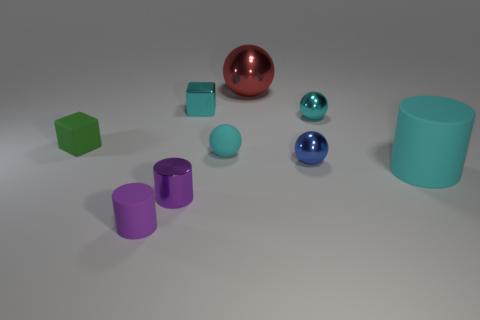Are there an equal number of tiny green blocks in front of the tiny green thing and tiny cylinders?
Keep it short and to the point. No. The purple matte thing that is the same shape as the purple metal object is what size?
Ensure brevity in your answer.  Small. There is a blue metal object; does it have the same shape as the object to the left of the small purple rubber cylinder?
Make the answer very short. No. What size is the purple cylinder that is in front of the tiny purple object that is behind the small purple rubber object?
Provide a short and direct response. Small. Are there the same number of cyan metallic objects that are in front of the small blue sphere and red balls behind the tiny cyan matte ball?
Give a very brief answer. No. The other small metal object that is the same shape as the small blue object is what color?
Your answer should be very brief. Cyan. How many small rubber spheres are the same color as the large matte thing?
Offer a very short reply. 1. There is a small matte thing that is left of the small purple matte object; does it have the same shape as the small blue object?
Offer a very short reply. No. What is the shape of the purple object in front of the small cylinder that is on the right side of the small purple cylinder that is on the left side of the tiny metallic cylinder?
Your answer should be very brief. Cylinder. What size is the blue object?
Keep it short and to the point. Small. 